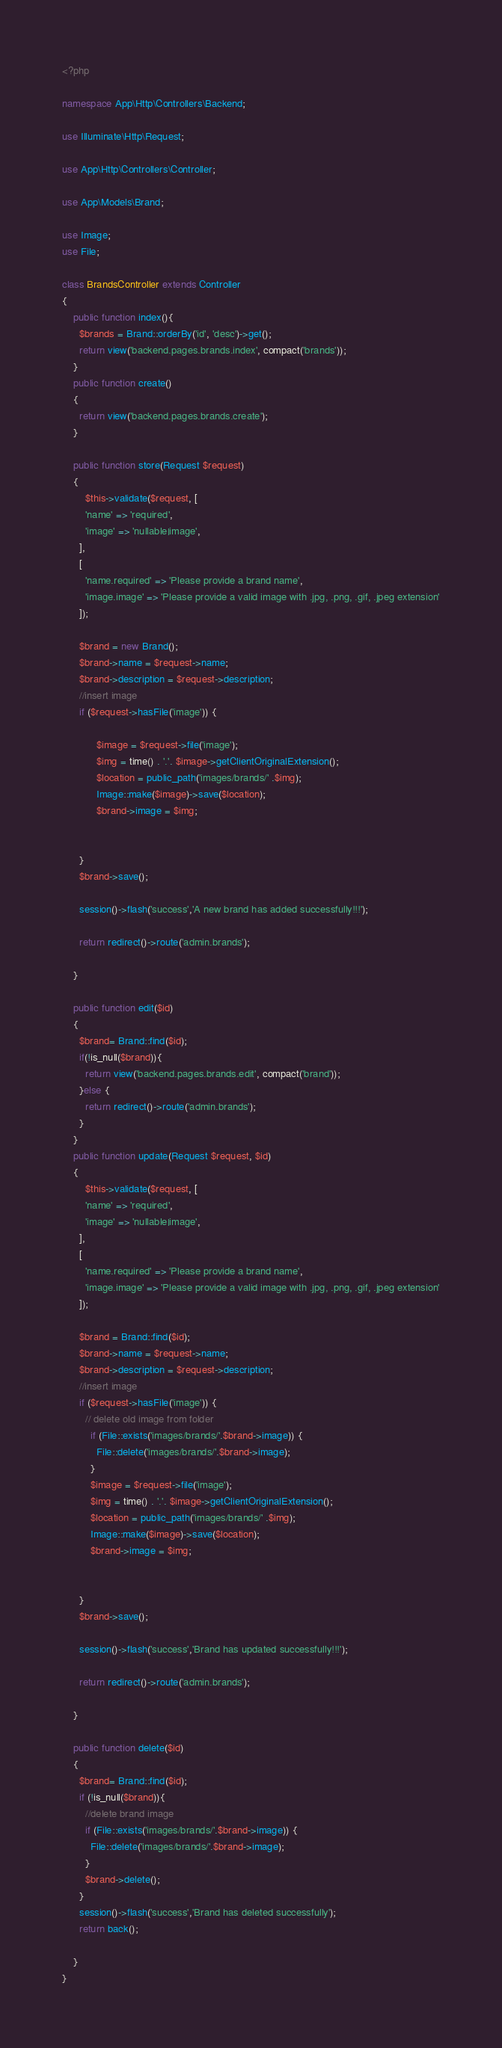Convert code to text. <code><loc_0><loc_0><loc_500><loc_500><_PHP_><?php

namespace App\Http\Controllers\Backend;

use Illuminate\Http\Request;

use App\Http\Controllers\Controller;

use App\Models\Brand;

use Image;
use File;

class BrandsController extends Controller
{
    public function index(){
      $brands = Brand::orderBy('id', 'desc')->get();
      return view('backend.pages.brands.index', compact('brands'));
    }
    public function create()
    {
      return view('backend.pages.brands.create');
    }

    public function store(Request $request)
    {
        $this->validate($request, [
        'name' => 'required',
        'image' => 'nullable|image',
      ],
      [
        'name.required' => 'Please provide a brand name',
        'image.image' => 'Please provide a valid image with .jpg, .png, .gif, .jpeg extension'
      ]);

      $brand = new Brand();
      $brand->name = $request->name;
      $brand->description = $request->description;
      //insert image
      if ($request->hasFile('image')) {

            $image = $request->file('image');
            $img = time() . '.'. $image->getClientOriginalExtension();
            $location = public_path('images/brands/' .$img);
            Image::make($image)->save($location);
            $brand->image = $img;


      }
      $brand->save();

      session()->flash('success','A new brand has added successfully!!!');

      return redirect()->route('admin.brands');

    }

    public function edit($id)
    {
      $brand= Brand::find($id);
      if(!is_null($brand)){
        return view('backend.pages.brands.edit', compact('brand'));
      }else {
        return redirect()->route('admin.brands');
      }
    }
    public function update(Request $request, $id)
    {
        $this->validate($request, [
        'name' => 'required',
        'image' => 'nullable|image',
      ],
      [
        'name.required' => 'Please provide a brand name',
        'image.image' => 'Please provide a valid image with .jpg, .png, .gif, .jpeg extension'
      ]);

      $brand = Brand::find($id);
      $brand->name = $request->name;
      $brand->description = $request->description;
      //insert image
      if ($request->hasFile('image')) {
        // delete old image from folder
          if (File::exists('images/brands/'.$brand->image)) {
            File::delete('images/brands/'.$brand->image);
          }
          $image = $request->file('image');
          $img = time() . '.'. $image->getClientOriginalExtension();
          $location = public_path('images/brands/' .$img);
          Image::make($image)->save($location);
          $brand->image = $img;


      }
      $brand->save();

      session()->flash('success','Brand has updated successfully!!!');

      return redirect()->route('admin.brands');

    }

    public function delete($id)
    {
      $brand= Brand::find($id);
      if (!is_null($brand)){
        //delete brand image
        if (File::exists('images/brands/'.$brand->image)) {
          File::delete('images/brands/'.$brand->image);
        }
        $brand->delete();
      }
      session()->flash('success','Brand has deleted successfully');
      return back();

    }
}
</code> 